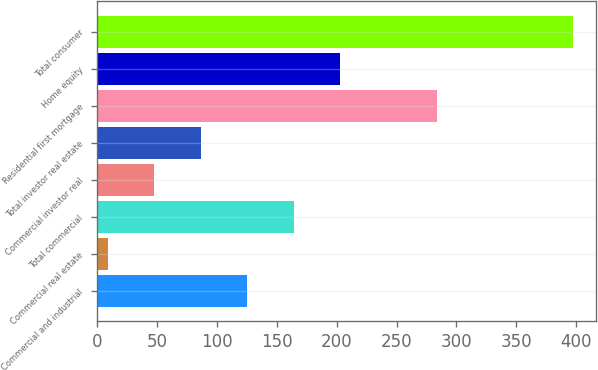<chart> <loc_0><loc_0><loc_500><loc_500><bar_chart><fcel>Commercial and industrial<fcel>Commercial real estate<fcel>Total commercial<fcel>Commercial investor real<fcel>Total investor real estate<fcel>Residential first mortgage<fcel>Home equity<fcel>Total consumer<nl><fcel>125.4<fcel>9<fcel>164.2<fcel>47.8<fcel>86.6<fcel>284<fcel>203<fcel>397<nl></chart> 